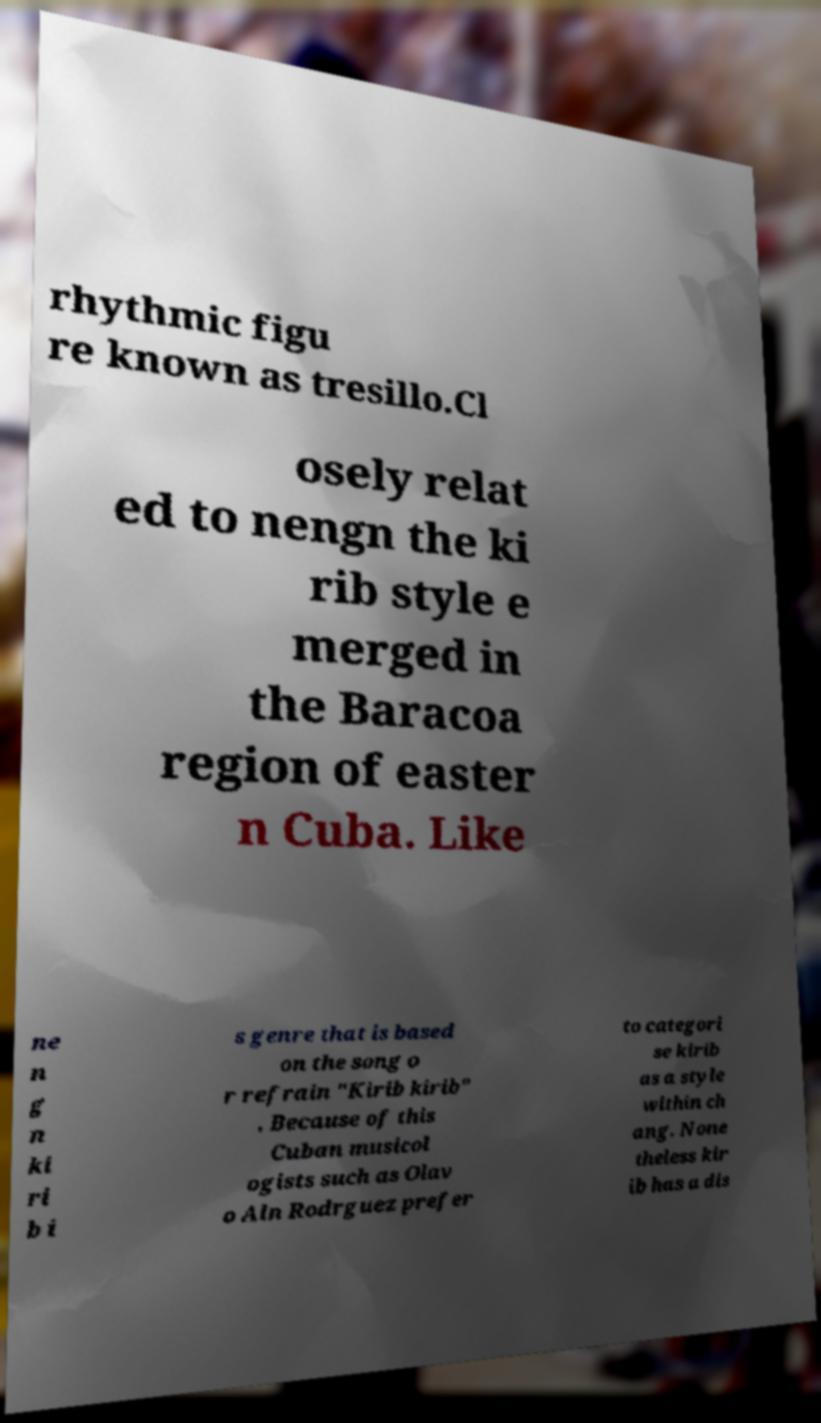Can you accurately transcribe the text from the provided image for me? rhythmic figu re known as tresillo.Cl osely relat ed to nengn the ki rib style e merged in the Baracoa region of easter n Cuba. Like ne n g n ki ri b i s genre that is based on the song o r refrain "Kirib kirib" . Because of this Cuban musicol ogists such as Olav o Aln Rodrguez prefer to categori se kirib as a style within ch ang. None theless kir ib has a dis 